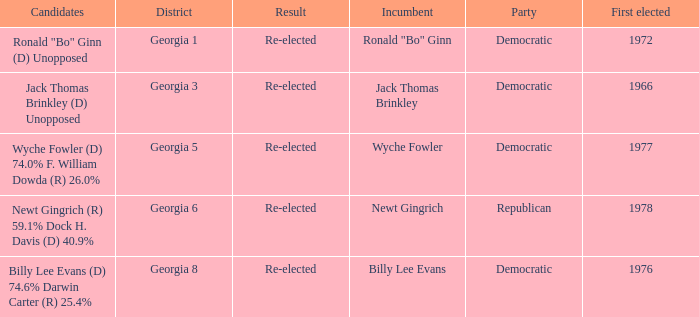How many incumbents were for district georgia 6? 1.0. 